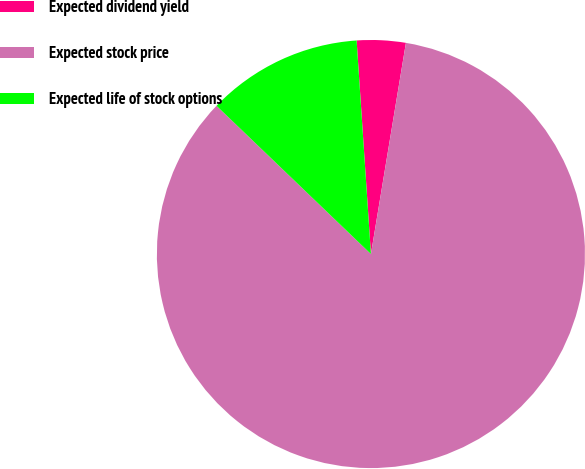Convert chart to OTSL. <chart><loc_0><loc_0><loc_500><loc_500><pie_chart><fcel>Expected dividend yield<fcel>Expected stock price<fcel>Expected life of stock options<nl><fcel>3.68%<fcel>84.56%<fcel>11.76%<nl></chart> 